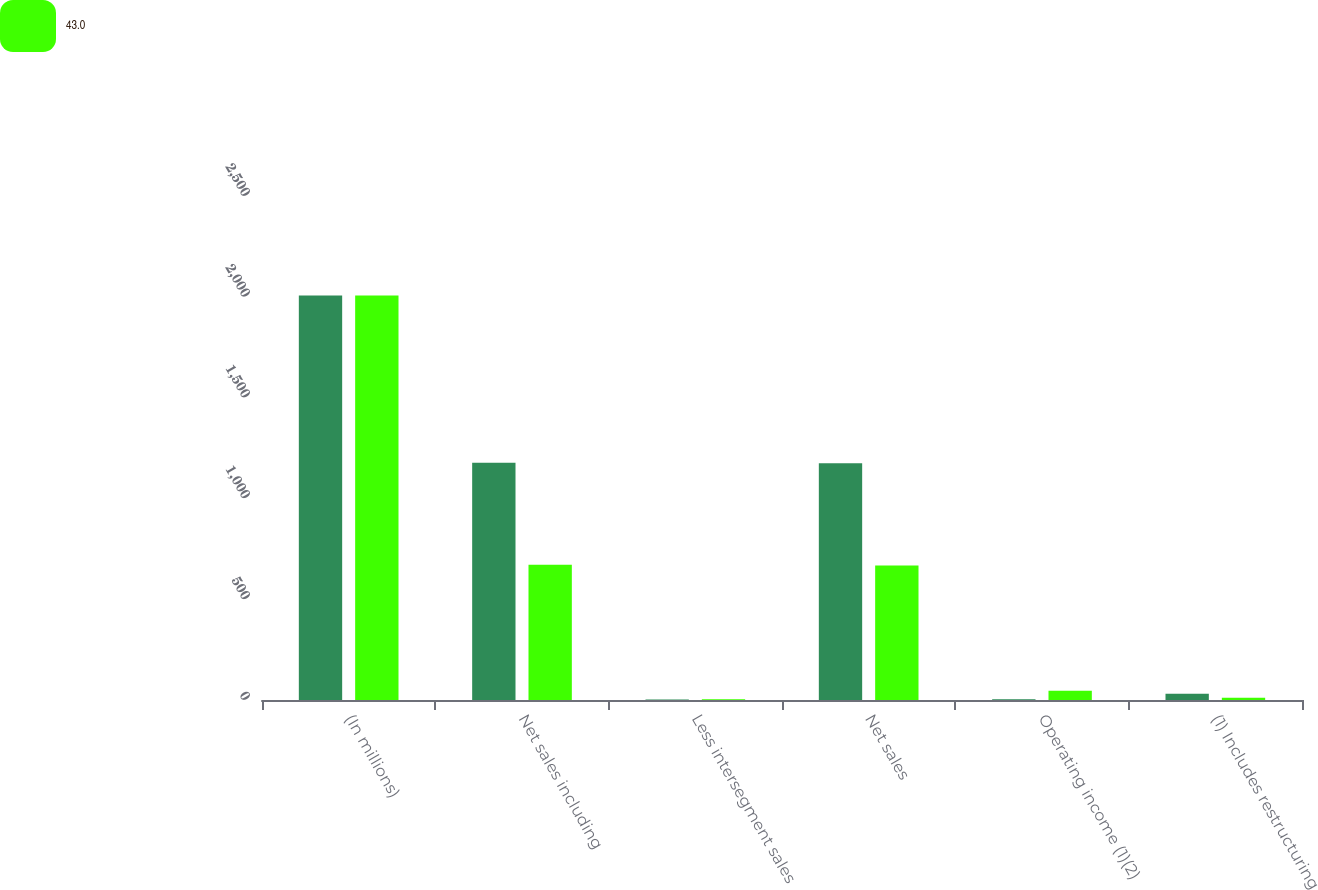<chart> <loc_0><loc_0><loc_500><loc_500><stacked_bar_chart><ecel><fcel>(In millions)<fcel>Net sales including<fcel>Less intersegment sales<fcel>Net sales<fcel>Operating income (1)(2)<fcel>(1) Includes restructuring<nl><fcel>nan<fcel>2007<fcel>1176.6<fcel>2.1<fcel>1174.5<fcel>4<fcel>31.2<nl><fcel>43<fcel>2006<fcel>671.1<fcel>3.4<fcel>667.7<fcel>45.7<fcel>11.2<nl></chart> 